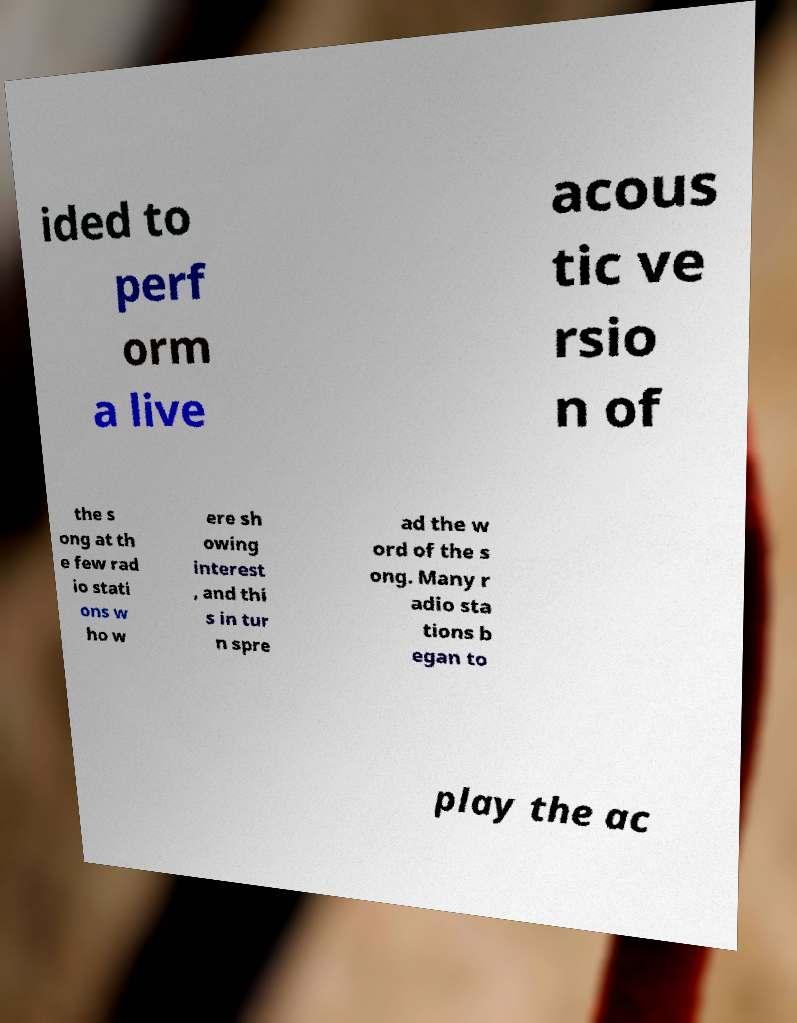Can you accurately transcribe the text from the provided image for me? ided to perf orm a live acous tic ve rsio n of the s ong at th e few rad io stati ons w ho w ere sh owing interest , and thi s in tur n spre ad the w ord of the s ong. Many r adio sta tions b egan to play the ac 